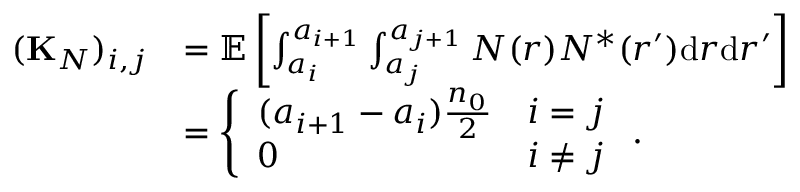<formula> <loc_0><loc_0><loc_500><loc_500>\begin{array} { r l } { ( { K } _ { N } ) _ { i , j } } & { = { \mathbb { E } } \left [ \int _ { a _ { i } } ^ { a _ { i + 1 } } \int _ { a _ { j } } ^ { a _ { j + 1 } } N ( r ) N ^ { * } ( r ^ { \prime } ) d r d r ^ { \prime } \right ] } \\ & { = \left \{ \begin{array} { l l } { ( a _ { i + 1 } - a _ { i } ) \frac { n _ { 0 } } { 2 } } & { i = j } \\ { 0 } & { i \ne j } \end{array} . } \end{array}</formula> 